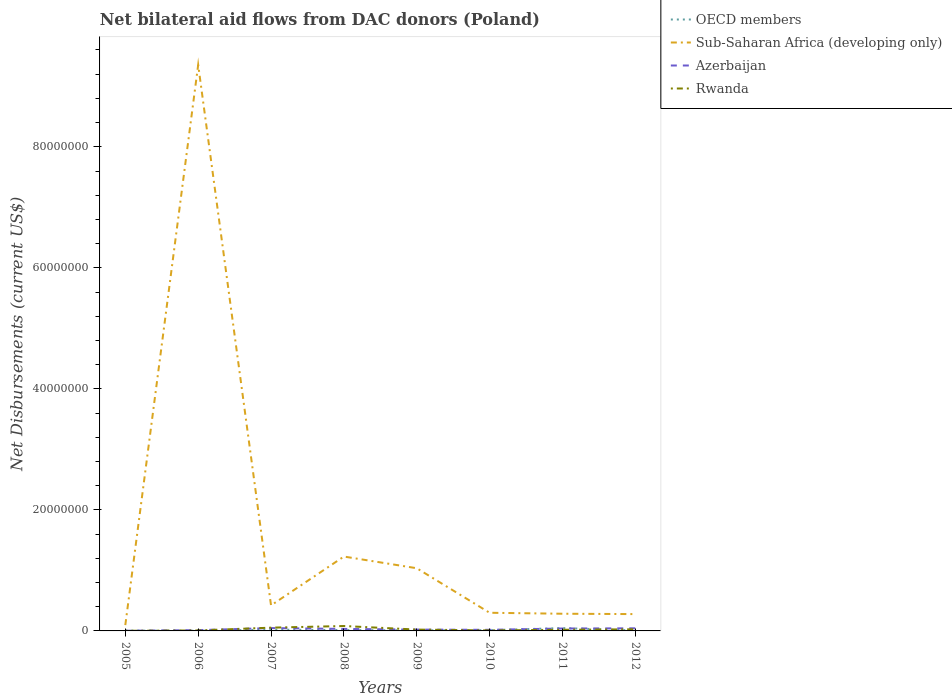How many different coloured lines are there?
Provide a succinct answer. 4. Is the number of lines equal to the number of legend labels?
Your response must be concise. Yes. Across all years, what is the maximum net bilateral aid flows in Sub-Saharan Africa (developing only)?
Offer a very short reply. 9.60e+05. What is the total net bilateral aid flows in Sub-Saharan Africa (developing only) in the graph?
Provide a short and direct response. 1.38e+06. What is the difference between the highest and the second highest net bilateral aid flows in Rwanda?
Your answer should be very brief. 7.90e+05. Does the graph contain any zero values?
Give a very brief answer. No. Does the graph contain grids?
Your response must be concise. No. How are the legend labels stacked?
Your answer should be very brief. Vertical. What is the title of the graph?
Your response must be concise. Net bilateral aid flows from DAC donors (Poland). What is the label or title of the X-axis?
Give a very brief answer. Years. What is the label or title of the Y-axis?
Keep it short and to the point. Net Disbursements (current US$). What is the Net Disbursements (current US$) in Sub-Saharan Africa (developing only) in 2005?
Provide a short and direct response. 9.60e+05. What is the Net Disbursements (current US$) of Azerbaijan in 2005?
Your answer should be compact. 3.00e+04. What is the Net Disbursements (current US$) in OECD members in 2006?
Keep it short and to the point. 3.00e+04. What is the Net Disbursements (current US$) of Sub-Saharan Africa (developing only) in 2006?
Make the answer very short. 9.35e+07. What is the Net Disbursements (current US$) in Sub-Saharan Africa (developing only) in 2007?
Provide a succinct answer. 4.22e+06. What is the Net Disbursements (current US$) in Azerbaijan in 2007?
Give a very brief answer. 4.70e+05. What is the Net Disbursements (current US$) in Rwanda in 2007?
Your answer should be compact. 5.40e+05. What is the Net Disbursements (current US$) in Sub-Saharan Africa (developing only) in 2008?
Your response must be concise. 1.23e+07. What is the Net Disbursements (current US$) in Azerbaijan in 2008?
Keep it short and to the point. 3.30e+05. What is the Net Disbursements (current US$) of Rwanda in 2008?
Your response must be concise. 8.10e+05. What is the Net Disbursements (current US$) in Sub-Saharan Africa (developing only) in 2009?
Your response must be concise. 1.04e+07. What is the Net Disbursements (current US$) in Azerbaijan in 2009?
Keep it short and to the point. 2.20e+05. What is the Net Disbursements (current US$) in Rwanda in 2009?
Provide a short and direct response. 2.20e+05. What is the Net Disbursements (current US$) of OECD members in 2010?
Your answer should be very brief. 1.20e+05. What is the Net Disbursements (current US$) of Azerbaijan in 2010?
Offer a terse response. 1.80e+05. What is the Net Disbursements (current US$) of Rwanda in 2010?
Ensure brevity in your answer.  8.00e+04. What is the Net Disbursements (current US$) in Sub-Saharan Africa (developing only) in 2011?
Your answer should be very brief. 2.84e+06. What is the Net Disbursements (current US$) of OECD members in 2012?
Ensure brevity in your answer.  7.00e+04. What is the Net Disbursements (current US$) in Sub-Saharan Africa (developing only) in 2012?
Your answer should be compact. 2.78e+06. What is the Net Disbursements (current US$) of Rwanda in 2012?
Offer a very short reply. 2.70e+05. Across all years, what is the maximum Net Disbursements (current US$) in Sub-Saharan Africa (developing only)?
Your answer should be compact. 9.35e+07. Across all years, what is the maximum Net Disbursements (current US$) of Azerbaijan?
Offer a terse response. 4.70e+05. Across all years, what is the maximum Net Disbursements (current US$) of Rwanda?
Provide a succinct answer. 8.10e+05. Across all years, what is the minimum Net Disbursements (current US$) of OECD members?
Offer a very short reply. 3.00e+04. Across all years, what is the minimum Net Disbursements (current US$) in Sub-Saharan Africa (developing only)?
Your answer should be very brief. 9.60e+05. What is the total Net Disbursements (current US$) of OECD members in the graph?
Your answer should be compact. 1.18e+06. What is the total Net Disbursements (current US$) in Sub-Saharan Africa (developing only) in the graph?
Keep it short and to the point. 1.30e+08. What is the total Net Disbursements (current US$) of Azerbaijan in the graph?
Ensure brevity in your answer.  2.19e+06. What is the total Net Disbursements (current US$) of Rwanda in the graph?
Provide a short and direct response. 2.21e+06. What is the difference between the Net Disbursements (current US$) of Sub-Saharan Africa (developing only) in 2005 and that in 2006?
Ensure brevity in your answer.  -9.26e+07. What is the difference between the Net Disbursements (current US$) of Azerbaijan in 2005 and that in 2006?
Your answer should be compact. -1.00e+05. What is the difference between the Net Disbursements (current US$) in Rwanda in 2005 and that in 2006?
Your answer should be compact. -6.00e+04. What is the difference between the Net Disbursements (current US$) in Sub-Saharan Africa (developing only) in 2005 and that in 2007?
Keep it short and to the point. -3.26e+06. What is the difference between the Net Disbursements (current US$) of Azerbaijan in 2005 and that in 2007?
Provide a short and direct response. -4.40e+05. What is the difference between the Net Disbursements (current US$) in Rwanda in 2005 and that in 2007?
Provide a short and direct response. -5.20e+05. What is the difference between the Net Disbursements (current US$) of Sub-Saharan Africa (developing only) in 2005 and that in 2008?
Provide a succinct answer. -1.13e+07. What is the difference between the Net Disbursements (current US$) of Rwanda in 2005 and that in 2008?
Your answer should be very brief. -7.90e+05. What is the difference between the Net Disbursements (current US$) in Sub-Saharan Africa (developing only) in 2005 and that in 2009?
Your answer should be compact. -9.40e+06. What is the difference between the Net Disbursements (current US$) of Azerbaijan in 2005 and that in 2009?
Provide a short and direct response. -1.90e+05. What is the difference between the Net Disbursements (current US$) in OECD members in 2005 and that in 2010?
Keep it short and to the point. -7.00e+04. What is the difference between the Net Disbursements (current US$) of Sub-Saharan Africa (developing only) in 2005 and that in 2010?
Keep it short and to the point. -2.04e+06. What is the difference between the Net Disbursements (current US$) in Azerbaijan in 2005 and that in 2010?
Ensure brevity in your answer.  -1.50e+05. What is the difference between the Net Disbursements (current US$) of OECD members in 2005 and that in 2011?
Your answer should be very brief. -4.20e+05. What is the difference between the Net Disbursements (current US$) of Sub-Saharan Africa (developing only) in 2005 and that in 2011?
Your answer should be very brief. -1.88e+06. What is the difference between the Net Disbursements (current US$) of Azerbaijan in 2005 and that in 2011?
Keep it short and to the point. -3.70e+05. What is the difference between the Net Disbursements (current US$) in Rwanda in 2005 and that in 2011?
Provide a short and direct response. -1.70e+05. What is the difference between the Net Disbursements (current US$) of OECD members in 2005 and that in 2012?
Your answer should be compact. -2.00e+04. What is the difference between the Net Disbursements (current US$) in Sub-Saharan Africa (developing only) in 2005 and that in 2012?
Keep it short and to the point. -1.82e+06. What is the difference between the Net Disbursements (current US$) in Azerbaijan in 2005 and that in 2012?
Your answer should be very brief. -4.00e+05. What is the difference between the Net Disbursements (current US$) in Rwanda in 2005 and that in 2012?
Your answer should be compact. -2.50e+05. What is the difference between the Net Disbursements (current US$) in Sub-Saharan Africa (developing only) in 2006 and that in 2007?
Keep it short and to the point. 8.93e+07. What is the difference between the Net Disbursements (current US$) in Rwanda in 2006 and that in 2007?
Provide a succinct answer. -4.60e+05. What is the difference between the Net Disbursements (current US$) of OECD members in 2006 and that in 2008?
Make the answer very short. -1.10e+05. What is the difference between the Net Disbursements (current US$) in Sub-Saharan Africa (developing only) in 2006 and that in 2008?
Give a very brief answer. 8.12e+07. What is the difference between the Net Disbursements (current US$) of Rwanda in 2006 and that in 2008?
Offer a terse response. -7.30e+05. What is the difference between the Net Disbursements (current US$) of OECD members in 2006 and that in 2009?
Make the answer very short. -6.00e+04. What is the difference between the Net Disbursements (current US$) in Sub-Saharan Africa (developing only) in 2006 and that in 2009?
Provide a short and direct response. 8.32e+07. What is the difference between the Net Disbursements (current US$) of Azerbaijan in 2006 and that in 2009?
Your response must be concise. -9.00e+04. What is the difference between the Net Disbursements (current US$) in Sub-Saharan Africa (developing only) in 2006 and that in 2010?
Offer a terse response. 9.05e+07. What is the difference between the Net Disbursements (current US$) of Rwanda in 2006 and that in 2010?
Keep it short and to the point. 0. What is the difference between the Net Disbursements (current US$) in OECD members in 2006 and that in 2011?
Keep it short and to the point. -4.40e+05. What is the difference between the Net Disbursements (current US$) of Sub-Saharan Africa (developing only) in 2006 and that in 2011?
Your response must be concise. 9.07e+07. What is the difference between the Net Disbursements (current US$) in Azerbaijan in 2006 and that in 2011?
Give a very brief answer. -2.70e+05. What is the difference between the Net Disbursements (current US$) in Sub-Saharan Africa (developing only) in 2006 and that in 2012?
Ensure brevity in your answer.  9.08e+07. What is the difference between the Net Disbursements (current US$) of Rwanda in 2006 and that in 2012?
Ensure brevity in your answer.  -1.90e+05. What is the difference between the Net Disbursements (current US$) of Sub-Saharan Africa (developing only) in 2007 and that in 2008?
Provide a short and direct response. -8.07e+06. What is the difference between the Net Disbursements (current US$) of Azerbaijan in 2007 and that in 2008?
Provide a succinct answer. 1.40e+05. What is the difference between the Net Disbursements (current US$) in Rwanda in 2007 and that in 2008?
Keep it short and to the point. -2.70e+05. What is the difference between the Net Disbursements (current US$) in Sub-Saharan Africa (developing only) in 2007 and that in 2009?
Your answer should be compact. -6.14e+06. What is the difference between the Net Disbursements (current US$) of Rwanda in 2007 and that in 2009?
Give a very brief answer. 3.20e+05. What is the difference between the Net Disbursements (current US$) in Sub-Saharan Africa (developing only) in 2007 and that in 2010?
Your response must be concise. 1.22e+06. What is the difference between the Net Disbursements (current US$) in Azerbaijan in 2007 and that in 2010?
Your answer should be very brief. 2.90e+05. What is the difference between the Net Disbursements (current US$) of Rwanda in 2007 and that in 2010?
Keep it short and to the point. 4.60e+05. What is the difference between the Net Disbursements (current US$) of OECD members in 2007 and that in 2011?
Offer a terse response. -2.60e+05. What is the difference between the Net Disbursements (current US$) in Sub-Saharan Africa (developing only) in 2007 and that in 2011?
Offer a terse response. 1.38e+06. What is the difference between the Net Disbursements (current US$) of Azerbaijan in 2007 and that in 2011?
Keep it short and to the point. 7.00e+04. What is the difference between the Net Disbursements (current US$) of Rwanda in 2007 and that in 2011?
Provide a short and direct response. 3.50e+05. What is the difference between the Net Disbursements (current US$) of OECD members in 2007 and that in 2012?
Make the answer very short. 1.40e+05. What is the difference between the Net Disbursements (current US$) of Sub-Saharan Africa (developing only) in 2007 and that in 2012?
Offer a very short reply. 1.44e+06. What is the difference between the Net Disbursements (current US$) of Rwanda in 2007 and that in 2012?
Give a very brief answer. 2.70e+05. What is the difference between the Net Disbursements (current US$) in OECD members in 2008 and that in 2009?
Your answer should be very brief. 5.00e+04. What is the difference between the Net Disbursements (current US$) of Sub-Saharan Africa (developing only) in 2008 and that in 2009?
Your answer should be very brief. 1.93e+06. What is the difference between the Net Disbursements (current US$) of Azerbaijan in 2008 and that in 2009?
Your answer should be compact. 1.10e+05. What is the difference between the Net Disbursements (current US$) in Rwanda in 2008 and that in 2009?
Offer a terse response. 5.90e+05. What is the difference between the Net Disbursements (current US$) in Sub-Saharan Africa (developing only) in 2008 and that in 2010?
Keep it short and to the point. 9.29e+06. What is the difference between the Net Disbursements (current US$) in Rwanda in 2008 and that in 2010?
Ensure brevity in your answer.  7.30e+05. What is the difference between the Net Disbursements (current US$) in OECD members in 2008 and that in 2011?
Offer a terse response. -3.30e+05. What is the difference between the Net Disbursements (current US$) of Sub-Saharan Africa (developing only) in 2008 and that in 2011?
Give a very brief answer. 9.45e+06. What is the difference between the Net Disbursements (current US$) in Rwanda in 2008 and that in 2011?
Your answer should be compact. 6.20e+05. What is the difference between the Net Disbursements (current US$) in OECD members in 2008 and that in 2012?
Ensure brevity in your answer.  7.00e+04. What is the difference between the Net Disbursements (current US$) of Sub-Saharan Africa (developing only) in 2008 and that in 2012?
Offer a very short reply. 9.51e+06. What is the difference between the Net Disbursements (current US$) of Rwanda in 2008 and that in 2012?
Offer a terse response. 5.40e+05. What is the difference between the Net Disbursements (current US$) of OECD members in 2009 and that in 2010?
Your answer should be very brief. -3.00e+04. What is the difference between the Net Disbursements (current US$) in Sub-Saharan Africa (developing only) in 2009 and that in 2010?
Provide a succinct answer. 7.36e+06. What is the difference between the Net Disbursements (current US$) in OECD members in 2009 and that in 2011?
Give a very brief answer. -3.80e+05. What is the difference between the Net Disbursements (current US$) of Sub-Saharan Africa (developing only) in 2009 and that in 2011?
Offer a terse response. 7.52e+06. What is the difference between the Net Disbursements (current US$) in Rwanda in 2009 and that in 2011?
Your answer should be compact. 3.00e+04. What is the difference between the Net Disbursements (current US$) of Sub-Saharan Africa (developing only) in 2009 and that in 2012?
Your answer should be very brief. 7.58e+06. What is the difference between the Net Disbursements (current US$) of Azerbaijan in 2009 and that in 2012?
Your response must be concise. -2.10e+05. What is the difference between the Net Disbursements (current US$) in Rwanda in 2009 and that in 2012?
Keep it short and to the point. -5.00e+04. What is the difference between the Net Disbursements (current US$) in OECD members in 2010 and that in 2011?
Ensure brevity in your answer.  -3.50e+05. What is the difference between the Net Disbursements (current US$) in Sub-Saharan Africa (developing only) in 2010 and that in 2011?
Keep it short and to the point. 1.60e+05. What is the difference between the Net Disbursements (current US$) of Azerbaijan in 2010 and that in 2011?
Ensure brevity in your answer.  -2.20e+05. What is the difference between the Net Disbursements (current US$) in Rwanda in 2010 and that in 2011?
Give a very brief answer. -1.10e+05. What is the difference between the Net Disbursements (current US$) of OECD members in 2010 and that in 2012?
Ensure brevity in your answer.  5.00e+04. What is the difference between the Net Disbursements (current US$) in OECD members in 2005 and the Net Disbursements (current US$) in Sub-Saharan Africa (developing only) in 2006?
Offer a very short reply. -9.35e+07. What is the difference between the Net Disbursements (current US$) of Sub-Saharan Africa (developing only) in 2005 and the Net Disbursements (current US$) of Azerbaijan in 2006?
Provide a short and direct response. 8.30e+05. What is the difference between the Net Disbursements (current US$) in Sub-Saharan Africa (developing only) in 2005 and the Net Disbursements (current US$) in Rwanda in 2006?
Your response must be concise. 8.80e+05. What is the difference between the Net Disbursements (current US$) in Azerbaijan in 2005 and the Net Disbursements (current US$) in Rwanda in 2006?
Give a very brief answer. -5.00e+04. What is the difference between the Net Disbursements (current US$) of OECD members in 2005 and the Net Disbursements (current US$) of Sub-Saharan Africa (developing only) in 2007?
Give a very brief answer. -4.17e+06. What is the difference between the Net Disbursements (current US$) in OECD members in 2005 and the Net Disbursements (current US$) in Azerbaijan in 2007?
Give a very brief answer. -4.20e+05. What is the difference between the Net Disbursements (current US$) in OECD members in 2005 and the Net Disbursements (current US$) in Rwanda in 2007?
Your answer should be very brief. -4.90e+05. What is the difference between the Net Disbursements (current US$) of Sub-Saharan Africa (developing only) in 2005 and the Net Disbursements (current US$) of Azerbaijan in 2007?
Your answer should be very brief. 4.90e+05. What is the difference between the Net Disbursements (current US$) of Azerbaijan in 2005 and the Net Disbursements (current US$) of Rwanda in 2007?
Keep it short and to the point. -5.10e+05. What is the difference between the Net Disbursements (current US$) in OECD members in 2005 and the Net Disbursements (current US$) in Sub-Saharan Africa (developing only) in 2008?
Your answer should be very brief. -1.22e+07. What is the difference between the Net Disbursements (current US$) in OECD members in 2005 and the Net Disbursements (current US$) in Azerbaijan in 2008?
Make the answer very short. -2.80e+05. What is the difference between the Net Disbursements (current US$) in OECD members in 2005 and the Net Disbursements (current US$) in Rwanda in 2008?
Provide a succinct answer. -7.60e+05. What is the difference between the Net Disbursements (current US$) of Sub-Saharan Africa (developing only) in 2005 and the Net Disbursements (current US$) of Azerbaijan in 2008?
Give a very brief answer. 6.30e+05. What is the difference between the Net Disbursements (current US$) of Azerbaijan in 2005 and the Net Disbursements (current US$) of Rwanda in 2008?
Make the answer very short. -7.80e+05. What is the difference between the Net Disbursements (current US$) of OECD members in 2005 and the Net Disbursements (current US$) of Sub-Saharan Africa (developing only) in 2009?
Your answer should be very brief. -1.03e+07. What is the difference between the Net Disbursements (current US$) in OECD members in 2005 and the Net Disbursements (current US$) in Rwanda in 2009?
Provide a short and direct response. -1.70e+05. What is the difference between the Net Disbursements (current US$) of Sub-Saharan Africa (developing only) in 2005 and the Net Disbursements (current US$) of Azerbaijan in 2009?
Your answer should be very brief. 7.40e+05. What is the difference between the Net Disbursements (current US$) of Sub-Saharan Africa (developing only) in 2005 and the Net Disbursements (current US$) of Rwanda in 2009?
Make the answer very short. 7.40e+05. What is the difference between the Net Disbursements (current US$) of Azerbaijan in 2005 and the Net Disbursements (current US$) of Rwanda in 2009?
Your response must be concise. -1.90e+05. What is the difference between the Net Disbursements (current US$) in OECD members in 2005 and the Net Disbursements (current US$) in Sub-Saharan Africa (developing only) in 2010?
Make the answer very short. -2.95e+06. What is the difference between the Net Disbursements (current US$) of OECD members in 2005 and the Net Disbursements (current US$) of Azerbaijan in 2010?
Make the answer very short. -1.30e+05. What is the difference between the Net Disbursements (current US$) of Sub-Saharan Africa (developing only) in 2005 and the Net Disbursements (current US$) of Azerbaijan in 2010?
Your answer should be very brief. 7.80e+05. What is the difference between the Net Disbursements (current US$) in Sub-Saharan Africa (developing only) in 2005 and the Net Disbursements (current US$) in Rwanda in 2010?
Provide a succinct answer. 8.80e+05. What is the difference between the Net Disbursements (current US$) of Azerbaijan in 2005 and the Net Disbursements (current US$) of Rwanda in 2010?
Make the answer very short. -5.00e+04. What is the difference between the Net Disbursements (current US$) of OECD members in 2005 and the Net Disbursements (current US$) of Sub-Saharan Africa (developing only) in 2011?
Provide a succinct answer. -2.79e+06. What is the difference between the Net Disbursements (current US$) of OECD members in 2005 and the Net Disbursements (current US$) of Azerbaijan in 2011?
Your answer should be compact. -3.50e+05. What is the difference between the Net Disbursements (current US$) in Sub-Saharan Africa (developing only) in 2005 and the Net Disbursements (current US$) in Azerbaijan in 2011?
Provide a short and direct response. 5.60e+05. What is the difference between the Net Disbursements (current US$) in Sub-Saharan Africa (developing only) in 2005 and the Net Disbursements (current US$) in Rwanda in 2011?
Your response must be concise. 7.70e+05. What is the difference between the Net Disbursements (current US$) of OECD members in 2005 and the Net Disbursements (current US$) of Sub-Saharan Africa (developing only) in 2012?
Provide a short and direct response. -2.73e+06. What is the difference between the Net Disbursements (current US$) in OECD members in 2005 and the Net Disbursements (current US$) in Azerbaijan in 2012?
Provide a succinct answer. -3.80e+05. What is the difference between the Net Disbursements (current US$) in Sub-Saharan Africa (developing only) in 2005 and the Net Disbursements (current US$) in Azerbaijan in 2012?
Offer a very short reply. 5.30e+05. What is the difference between the Net Disbursements (current US$) of Sub-Saharan Africa (developing only) in 2005 and the Net Disbursements (current US$) of Rwanda in 2012?
Ensure brevity in your answer.  6.90e+05. What is the difference between the Net Disbursements (current US$) in Azerbaijan in 2005 and the Net Disbursements (current US$) in Rwanda in 2012?
Ensure brevity in your answer.  -2.40e+05. What is the difference between the Net Disbursements (current US$) of OECD members in 2006 and the Net Disbursements (current US$) of Sub-Saharan Africa (developing only) in 2007?
Offer a terse response. -4.19e+06. What is the difference between the Net Disbursements (current US$) in OECD members in 2006 and the Net Disbursements (current US$) in Azerbaijan in 2007?
Make the answer very short. -4.40e+05. What is the difference between the Net Disbursements (current US$) of OECD members in 2006 and the Net Disbursements (current US$) of Rwanda in 2007?
Offer a very short reply. -5.10e+05. What is the difference between the Net Disbursements (current US$) in Sub-Saharan Africa (developing only) in 2006 and the Net Disbursements (current US$) in Azerbaijan in 2007?
Offer a terse response. 9.31e+07. What is the difference between the Net Disbursements (current US$) in Sub-Saharan Africa (developing only) in 2006 and the Net Disbursements (current US$) in Rwanda in 2007?
Offer a very short reply. 9.30e+07. What is the difference between the Net Disbursements (current US$) in Azerbaijan in 2006 and the Net Disbursements (current US$) in Rwanda in 2007?
Make the answer very short. -4.10e+05. What is the difference between the Net Disbursements (current US$) in OECD members in 2006 and the Net Disbursements (current US$) in Sub-Saharan Africa (developing only) in 2008?
Your answer should be very brief. -1.23e+07. What is the difference between the Net Disbursements (current US$) in OECD members in 2006 and the Net Disbursements (current US$) in Rwanda in 2008?
Keep it short and to the point. -7.80e+05. What is the difference between the Net Disbursements (current US$) of Sub-Saharan Africa (developing only) in 2006 and the Net Disbursements (current US$) of Azerbaijan in 2008?
Provide a short and direct response. 9.32e+07. What is the difference between the Net Disbursements (current US$) in Sub-Saharan Africa (developing only) in 2006 and the Net Disbursements (current US$) in Rwanda in 2008?
Keep it short and to the point. 9.27e+07. What is the difference between the Net Disbursements (current US$) of Azerbaijan in 2006 and the Net Disbursements (current US$) of Rwanda in 2008?
Give a very brief answer. -6.80e+05. What is the difference between the Net Disbursements (current US$) of OECD members in 2006 and the Net Disbursements (current US$) of Sub-Saharan Africa (developing only) in 2009?
Make the answer very short. -1.03e+07. What is the difference between the Net Disbursements (current US$) of Sub-Saharan Africa (developing only) in 2006 and the Net Disbursements (current US$) of Azerbaijan in 2009?
Make the answer very short. 9.33e+07. What is the difference between the Net Disbursements (current US$) in Sub-Saharan Africa (developing only) in 2006 and the Net Disbursements (current US$) in Rwanda in 2009?
Provide a short and direct response. 9.33e+07. What is the difference between the Net Disbursements (current US$) in Azerbaijan in 2006 and the Net Disbursements (current US$) in Rwanda in 2009?
Provide a succinct answer. -9.00e+04. What is the difference between the Net Disbursements (current US$) in OECD members in 2006 and the Net Disbursements (current US$) in Sub-Saharan Africa (developing only) in 2010?
Offer a terse response. -2.97e+06. What is the difference between the Net Disbursements (current US$) of OECD members in 2006 and the Net Disbursements (current US$) of Azerbaijan in 2010?
Your answer should be compact. -1.50e+05. What is the difference between the Net Disbursements (current US$) of OECD members in 2006 and the Net Disbursements (current US$) of Rwanda in 2010?
Provide a short and direct response. -5.00e+04. What is the difference between the Net Disbursements (current US$) of Sub-Saharan Africa (developing only) in 2006 and the Net Disbursements (current US$) of Azerbaijan in 2010?
Offer a terse response. 9.34e+07. What is the difference between the Net Disbursements (current US$) of Sub-Saharan Africa (developing only) in 2006 and the Net Disbursements (current US$) of Rwanda in 2010?
Offer a terse response. 9.35e+07. What is the difference between the Net Disbursements (current US$) in OECD members in 2006 and the Net Disbursements (current US$) in Sub-Saharan Africa (developing only) in 2011?
Provide a succinct answer. -2.81e+06. What is the difference between the Net Disbursements (current US$) of OECD members in 2006 and the Net Disbursements (current US$) of Azerbaijan in 2011?
Keep it short and to the point. -3.70e+05. What is the difference between the Net Disbursements (current US$) in Sub-Saharan Africa (developing only) in 2006 and the Net Disbursements (current US$) in Azerbaijan in 2011?
Offer a very short reply. 9.31e+07. What is the difference between the Net Disbursements (current US$) of Sub-Saharan Africa (developing only) in 2006 and the Net Disbursements (current US$) of Rwanda in 2011?
Offer a terse response. 9.34e+07. What is the difference between the Net Disbursements (current US$) in OECD members in 2006 and the Net Disbursements (current US$) in Sub-Saharan Africa (developing only) in 2012?
Your answer should be very brief. -2.75e+06. What is the difference between the Net Disbursements (current US$) in OECD members in 2006 and the Net Disbursements (current US$) in Azerbaijan in 2012?
Make the answer very short. -4.00e+05. What is the difference between the Net Disbursements (current US$) of OECD members in 2006 and the Net Disbursements (current US$) of Rwanda in 2012?
Your answer should be compact. -2.40e+05. What is the difference between the Net Disbursements (current US$) in Sub-Saharan Africa (developing only) in 2006 and the Net Disbursements (current US$) in Azerbaijan in 2012?
Your answer should be very brief. 9.31e+07. What is the difference between the Net Disbursements (current US$) in Sub-Saharan Africa (developing only) in 2006 and the Net Disbursements (current US$) in Rwanda in 2012?
Give a very brief answer. 9.33e+07. What is the difference between the Net Disbursements (current US$) in OECD members in 2007 and the Net Disbursements (current US$) in Sub-Saharan Africa (developing only) in 2008?
Offer a terse response. -1.21e+07. What is the difference between the Net Disbursements (current US$) in OECD members in 2007 and the Net Disbursements (current US$) in Rwanda in 2008?
Provide a succinct answer. -6.00e+05. What is the difference between the Net Disbursements (current US$) of Sub-Saharan Africa (developing only) in 2007 and the Net Disbursements (current US$) of Azerbaijan in 2008?
Provide a succinct answer. 3.89e+06. What is the difference between the Net Disbursements (current US$) of Sub-Saharan Africa (developing only) in 2007 and the Net Disbursements (current US$) of Rwanda in 2008?
Keep it short and to the point. 3.41e+06. What is the difference between the Net Disbursements (current US$) of Azerbaijan in 2007 and the Net Disbursements (current US$) of Rwanda in 2008?
Provide a short and direct response. -3.40e+05. What is the difference between the Net Disbursements (current US$) in OECD members in 2007 and the Net Disbursements (current US$) in Sub-Saharan Africa (developing only) in 2009?
Make the answer very short. -1.02e+07. What is the difference between the Net Disbursements (current US$) of OECD members in 2007 and the Net Disbursements (current US$) of Azerbaijan in 2009?
Your answer should be very brief. -10000. What is the difference between the Net Disbursements (current US$) of Sub-Saharan Africa (developing only) in 2007 and the Net Disbursements (current US$) of Azerbaijan in 2009?
Your answer should be compact. 4.00e+06. What is the difference between the Net Disbursements (current US$) of OECD members in 2007 and the Net Disbursements (current US$) of Sub-Saharan Africa (developing only) in 2010?
Provide a succinct answer. -2.79e+06. What is the difference between the Net Disbursements (current US$) in OECD members in 2007 and the Net Disbursements (current US$) in Azerbaijan in 2010?
Make the answer very short. 3.00e+04. What is the difference between the Net Disbursements (current US$) of Sub-Saharan Africa (developing only) in 2007 and the Net Disbursements (current US$) of Azerbaijan in 2010?
Offer a very short reply. 4.04e+06. What is the difference between the Net Disbursements (current US$) of Sub-Saharan Africa (developing only) in 2007 and the Net Disbursements (current US$) of Rwanda in 2010?
Keep it short and to the point. 4.14e+06. What is the difference between the Net Disbursements (current US$) in OECD members in 2007 and the Net Disbursements (current US$) in Sub-Saharan Africa (developing only) in 2011?
Your answer should be compact. -2.63e+06. What is the difference between the Net Disbursements (current US$) of OECD members in 2007 and the Net Disbursements (current US$) of Azerbaijan in 2011?
Your answer should be compact. -1.90e+05. What is the difference between the Net Disbursements (current US$) in OECD members in 2007 and the Net Disbursements (current US$) in Rwanda in 2011?
Give a very brief answer. 2.00e+04. What is the difference between the Net Disbursements (current US$) in Sub-Saharan Africa (developing only) in 2007 and the Net Disbursements (current US$) in Azerbaijan in 2011?
Offer a very short reply. 3.82e+06. What is the difference between the Net Disbursements (current US$) of Sub-Saharan Africa (developing only) in 2007 and the Net Disbursements (current US$) of Rwanda in 2011?
Ensure brevity in your answer.  4.03e+06. What is the difference between the Net Disbursements (current US$) in OECD members in 2007 and the Net Disbursements (current US$) in Sub-Saharan Africa (developing only) in 2012?
Keep it short and to the point. -2.57e+06. What is the difference between the Net Disbursements (current US$) in Sub-Saharan Africa (developing only) in 2007 and the Net Disbursements (current US$) in Azerbaijan in 2012?
Provide a short and direct response. 3.79e+06. What is the difference between the Net Disbursements (current US$) of Sub-Saharan Africa (developing only) in 2007 and the Net Disbursements (current US$) of Rwanda in 2012?
Make the answer very short. 3.95e+06. What is the difference between the Net Disbursements (current US$) of OECD members in 2008 and the Net Disbursements (current US$) of Sub-Saharan Africa (developing only) in 2009?
Ensure brevity in your answer.  -1.02e+07. What is the difference between the Net Disbursements (current US$) in OECD members in 2008 and the Net Disbursements (current US$) in Azerbaijan in 2009?
Offer a terse response. -8.00e+04. What is the difference between the Net Disbursements (current US$) in OECD members in 2008 and the Net Disbursements (current US$) in Rwanda in 2009?
Your answer should be compact. -8.00e+04. What is the difference between the Net Disbursements (current US$) in Sub-Saharan Africa (developing only) in 2008 and the Net Disbursements (current US$) in Azerbaijan in 2009?
Your response must be concise. 1.21e+07. What is the difference between the Net Disbursements (current US$) in Sub-Saharan Africa (developing only) in 2008 and the Net Disbursements (current US$) in Rwanda in 2009?
Provide a succinct answer. 1.21e+07. What is the difference between the Net Disbursements (current US$) in Azerbaijan in 2008 and the Net Disbursements (current US$) in Rwanda in 2009?
Give a very brief answer. 1.10e+05. What is the difference between the Net Disbursements (current US$) of OECD members in 2008 and the Net Disbursements (current US$) of Sub-Saharan Africa (developing only) in 2010?
Make the answer very short. -2.86e+06. What is the difference between the Net Disbursements (current US$) in OECD members in 2008 and the Net Disbursements (current US$) in Rwanda in 2010?
Your answer should be compact. 6.00e+04. What is the difference between the Net Disbursements (current US$) of Sub-Saharan Africa (developing only) in 2008 and the Net Disbursements (current US$) of Azerbaijan in 2010?
Your answer should be very brief. 1.21e+07. What is the difference between the Net Disbursements (current US$) in Sub-Saharan Africa (developing only) in 2008 and the Net Disbursements (current US$) in Rwanda in 2010?
Make the answer very short. 1.22e+07. What is the difference between the Net Disbursements (current US$) in Azerbaijan in 2008 and the Net Disbursements (current US$) in Rwanda in 2010?
Ensure brevity in your answer.  2.50e+05. What is the difference between the Net Disbursements (current US$) in OECD members in 2008 and the Net Disbursements (current US$) in Sub-Saharan Africa (developing only) in 2011?
Keep it short and to the point. -2.70e+06. What is the difference between the Net Disbursements (current US$) in Sub-Saharan Africa (developing only) in 2008 and the Net Disbursements (current US$) in Azerbaijan in 2011?
Make the answer very short. 1.19e+07. What is the difference between the Net Disbursements (current US$) of Sub-Saharan Africa (developing only) in 2008 and the Net Disbursements (current US$) of Rwanda in 2011?
Keep it short and to the point. 1.21e+07. What is the difference between the Net Disbursements (current US$) of Azerbaijan in 2008 and the Net Disbursements (current US$) of Rwanda in 2011?
Give a very brief answer. 1.40e+05. What is the difference between the Net Disbursements (current US$) in OECD members in 2008 and the Net Disbursements (current US$) in Sub-Saharan Africa (developing only) in 2012?
Keep it short and to the point. -2.64e+06. What is the difference between the Net Disbursements (current US$) of OECD members in 2008 and the Net Disbursements (current US$) of Azerbaijan in 2012?
Your answer should be compact. -2.90e+05. What is the difference between the Net Disbursements (current US$) of OECD members in 2008 and the Net Disbursements (current US$) of Rwanda in 2012?
Give a very brief answer. -1.30e+05. What is the difference between the Net Disbursements (current US$) of Sub-Saharan Africa (developing only) in 2008 and the Net Disbursements (current US$) of Azerbaijan in 2012?
Ensure brevity in your answer.  1.19e+07. What is the difference between the Net Disbursements (current US$) in Sub-Saharan Africa (developing only) in 2008 and the Net Disbursements (current US$) in Rwanda in 2012?
Give a very brief answer. 1.20e+07. What is the difference between the Net Disbursements (current US$) in Azerbaijan in 2008 and the Net Disbursements (current US$) in Rwanda in 2012?
Provide a succinct answer. 6.00e+04. What is the difference between the Net Disbursements (current US$) in OECD members in 2009 and the Net Disbursements (current US$) in Sub-Saharan Africa (developing only) in 2010?
Provide a short and direct response. -2.91e+06. What is the difference between the Net Disbursements (current US$) of Sub-Saharan Africa (developing only) in 2009 and the Net Disbursements (current US$) of Azerbaijan in 2010?
Give a very brief answer. 1.02e+07. What is the difference between the Net Disbursements (current US$) of Sub-Saharan Africa (developing only) in 2009 and the Net Disbursements (current US$) of Rwanda in 2010?
Offer a very short reply. 1.03e+07. What is the difference between the Net Disbursements (current US$) of OECD members in 2009 and the Net Disbursements (current US$) of Sub-Saharan Africa (developing only) in 2011?
Your response must be concise. -2.75e+06. What is the difference between the Net Disbursements (current US$) in OECD members in 2009 and the Net Disbursements (current US$) in Azerbaijan in 2011?
Give a very brief answer. -3.10e+05. What is the difference between the Net Disbursements (current US$) of OECD members in 2009 and the Net Disbursements (current US$) of Rwanda in 2011?
Provide a succinct answer. -1.00e+05. What is the difference between the Net Disbursements (current US$) in Sub-Saharan Africa (developing only) in 2009 and the Net Disbursements (current US$) in Azerbaijan in 2011?
Make the answer very short. 9.96e+06. What is the difference between the Net Disbursements (current US$) in Sub-Saharan Africa (developing only) in 2009 and the Net Disbursements (current US$) in Rwanda in 2011?
Offer a very short reply. 1.02e+07. What is the difference between the Net Disbursements (current US$) in Azerbaijan in 2009 and the Net Disbursements (current US$) in Rwanda in 2011?
Provide a succinct answer. 3.00e+04. What is the difference between the Net Disbursements (current US$) of OECD members in 2009 and the Net Disbursements (current US$) of Sub-Saharan Africa (developing only) in 2012?
Give a very brief answer. -2.69e+06. What is the difference between the Net Disbursements (current US$) in OECD members in 2009 and the Net Disbursements (current US$) in Rwanda in 2012?
Your answer should be very brief. -1.80e+05. What is the difference between the Net Disbursements (current US$) of Sub-Saharan Africa (developing only) in 2009 and the Net Disbursements (current US$) of Azerbaijan in 2012?
Give a very brief answer. 9.93e+06. What is the difference between the Net Disbursements (current US$) in Sub-Saharan Africa (developing only) in 2009 and the Net Disbursements (current US$) in Rwanda in 2012?
Make the answer very short. 1.01e+07. What is the difference between the Net Disbursements (current US$) of OECD members in 2010 and the Net Disbursements (current US$) of Sub-Saharan Africa (developing only) in 2011?
Give a very brief answer. -2.72e+06. What is the difference between the Net Disbursements (current US$) of OECD members in 2010 and the Net Disbursements (current US$) of Azerbaijan in 2011?
Make the answer very short. -2.80e+05. What is the difference between the Net Disbursements (current US$) of OECD members in 2010 and the Net Disbursements (current US$) of Rwanda in 2011?
Provide a short and direct response. -7.00e+04. What is the difference between the Net Disbursements (current US$) in Sub-Saharan Africa (developing only) in 2010 and the Net Disbursements (current US$) in Azerbaijan in 2011?
Offer a very short reply. 2.60e+06. What is the difference between the Net Disbursements (current US$) of Sub-Saharan Africa (developing only) in 2010 and the Net Disbursements (current US$) of Rwanda in 2011?
Your response must be concise. 2.81e+06. What is the difference between the Net Disbursements (current US$) in OECD members in 2010 and the Net Disbursements (current US$) in Sub-Saharan Africa (developing only) in 2012?
Offer a very short reply. -2.66e+06. What is the difference between the Net Disbursements (current US$) of OECD members in 2010 and the Net Disbursements (current US$) of Azerbaijan in 2012?
Keep it short and to the point. -3.10e+05. What is the difference between the Net Disbursements (current US$) in OECD members in 2010 and the Net Disbursements (current US$) in Rwanda in 2012?
Give a very brief answer. -1.50e+05. What is the difference between the Net Disbursements (current US$) of Sub-Saharan Africa (developing only) in 2010 and the Net Disbursements (current US$) of Azerbaijan in 2012?
Make the answer very short. 2.57e+06. What is the difference between the Net Disbursements (current US$) in Sub-Saharan Africa (developing only) in 2010 and the Net Disbursements (current US$) in Rwanda in 2012?
Your response must be concise. 2.73e+06. What is the difference between the Net Disbursements (current US$) in OECD members in 2011 and the Net Disbursements (current US$) in Sub-Saharan Africa (developing only) in 2012?
Give a very brief answer. -2.31e+06. What is the difference between the Net Disbursements (current US$) of OECD members in 2011 and the Net Disbursements (current US$) of Azerbaijan in 2012?
Ensure brevity in your answer.  4.00e+04. What is the difference between the Net Disbursements (current US$) in Sub-Saharan Africa (developing only) in 2011 and the Net Disbursements (current US$) in Azerbaijan in 2012?
Ensure brevity in your answer.  2.41e+06. What is the difference between the Net Disbursements (current US$) in Sub-Saharan Africa (developing only) in 2011 and the Net Disbursements (current US$) in Rwanda in 2012?
Your answer should be compact. 2.57e+06. What is the average Net Disbursements (current US$) of OECD members per year?
Offer a terse response. 1.48e+05. What is the average Net Disbursements (current US$) of Sub-Saharan Africa (developing only) per year?
Make the answer very short. 1.62e+07. What is the average Net Disbursements (current US$) of Azerbaijan per year?
Your answer should be very brief. 2.74e+05. What is the average Net Disbursements (current US$) in Rwanda per year?
Your response must be concise. 2.76e+05. In the year 2005, what is the difference between the Net Disbursements (current US$) of OECD members and Net Disbursements (current US$) of Sub-Saharan Africa (developing only)?
Offer a very short reply. -9.10e+05. In the year 2005, what is the difference between the Net Disbursements (current US$) in Sub-Saharan Africa (developing only) and Net Disbursements (current US$) in Azerbaijan?
Give a very brief answer. 9.30e+05. In the year 2005, what is the difference between the Net Disbursements (current US$) of Sub-Saharan Africa (developing only) and Net Disbursements (current US$) of Rwanda?
Your answer should be very brief. 9.40e+05. In the year 2005, what is the difference between the Net Disbursements (current US$) of Azerbaijan and Net Disbursements (current US$) of Rwanda?
Offer a terse response. 10000. In the year 2006, what is the difference between the Net Disbursements (current US$) of OECD members and Net Disbursements (current US$) of Sub-Saharan Africa (developing only)?
Your answer should be compact. -9.35e+07. In the year 2006, what is the difference between the Net Disbursements (current US$) of OECD members and Net Disbursements (current US$) of Azerbaijan?
Ensure brevity in your answer.  -1.00e+05. In the year 2006, what is the difference between the Net Disbursements (current US$) in OECD members and Net Disbursements (current US$) in Rwanda?
Provide a short and direct response. -5.00e+04. In the year 2006, what is the difference between the Net Disbursements (current US$) in Sub-Saharan Africa (developing only) and Net Disbursements (current US$) in Azerbaijan?
Your response must be concise. 9.34e+07. In the year 2006, what is the difference between the Net Disbursements (current US$) in Sub-Saharan Africa (developing only) and Net Disbursements (current US$) in Rwanda?
Keep it short and to the point. 9.35e+07. In the year 2006, what is the difference between the Net Disbursements (current US$) of Azerbaijan and Net Disbursements (current US$) of Rwanda?
Make the answer very short. 5.00e+04. In the year 2007, what is the difference between the Net Disbursements (current US$) of OECD members and Net Disbursements (current US$) of Sub-Saharan Africa (developing only)?
Keep it short and to the point. -4.01e+06. In the year 2007, what is the difference between the Net Disbursements (current US$) in OECD members and Net Disbursements (current US$) in Azerbaijan?
Ensure brevity in your answer.  -2.60e+05. In the year 2007, what is the difference between the Net Disbursements (current US$) in OECD members and Net Disbursements (current US$) in Rwanda?
Make the answer very short. -3.30e+05. In the year 2007, what is the difference between the Net Disbursements (current US$) in Sub-Saharan Africa (developing only) and Net Disbursements (current US$) in Azerbaijan?
Make the answer very short. 3.75e+06. In the year 2007, what is the difference between the Net Disbursements (current US$) of Sub-Saharan Africa (developing only) and Net Disbursements (current US$) of Rwanda?
Your response must be concise. 3.68e+06. In the year 2007, what is the difference between the Net Disbursements (current US$) in Azerbaijan and Net Disbursements (current US$) in Rwanda?
Ensure brevity in your answer.  -7.00e+04. In the year 2008, what is the difference between the Net Disbursements (current US$) in OECD members and Net Disbursements (current US$) in Sub-Saharan Africa (developing only)?
Your response must be concise. -1.22e+07. In the year 2008, what is the difference between the Net Disbursements (current US$) in OECD members and Net Disbursements (current US$) in Azerbaijan?
Your response must be concise. -1.90e+05. In the year 2008, what is the difference between the Net Disbursements (current US$) of OECD members and Net Disbursements (current US$) of Rwanda?
Give a very brief answer. -6.70e+05. In the year 2008, what is the difference between the Net Disbursements (current US$) of Sub-Saharan Africa (developing only) and Net Disbursements (current US$) of Azerbaijan?
Keep it short and to the point. 1.20e+07. In the year 2008, what is the difference between the Net Disbursements (current US$) in Sub-Saharan Africa (developing only) and Net Disbursements (current US$) in Rwanda?
Your answer should be compact. 1.15e+07. In the year 2008, what is the difference between the Net Disbursements (current US$) of Azerbaijan and Net Disbursements (current US$) of Rwanda?
Offer a very short reply. -4.80e+05. In the year 2009, what is the difference between the Net Disbursements (current US$) in OECD members and Net Disbursements (current US$) in Sub-Saharan Africa (developing only)?
Offer a terse response. -1.03e+07. In the year 2009, what is the difference between the Net Disbursements (current US$) in OECD members and Net Disbursements (current US$) in Azerbaijan?
Make the answer very short. -1.30e+05. In the year 2009, what is the difference between the Net Disbursements (current US$) in Sub-Saharan Africa (developing only) and Net Disbursements (current US$) in Azerbaijan?
Make the answer very short. 1.01e+07. In the year 2009, what is the difference between the Net Disbursements (current US$) in Sub-Saharan Africa (developing only) and Net Disbursements (current US$) in Rwanda?
Your response must be concise. 1.01e+07. In the year 2010, what is the difference between the Net Disbursements (current US$) in OECD members and Net Disbursements (current US$) in Sub-Saharan Africa (developing only)?
Provide a short and direct response. -2.88e+06. In the year 2010, what is the difference between the Net Disbursements (current US$) of OECD members and Net Disbursements (current US$) of Azerbaijan?
Keep it short and to the point. -6.00e+04. In the year 2010, what is the difference between the Net Disbursements (current US$) in Sub-Saharan Africa (developing only) and Net Disbursements (current US$) in Azerbaijan?
Your response must be concise. 2.82e+06. In the year 2010, what is the difference between the Net Disbursements (current US$) in Sub-Saharan Africa (developing only) and Net Disbursements (current US$) in Rwanda?
Your answer should be compact. 2.92e+06. In the year 2011, what is the difference between the Net Disbursements (current US$) of OECD members and Net Disbursements (current US$) of Sub-Saharan Africa (developing only)?
Make the answer very short. -2.37e+06. In the year 2011, what is the difference between the Net Disbursements (current US$) in OECD members and Net Disbursements (current US$) in Azerbaijan?
Your response must be concise. 7.00e+04. In the year 2011, what is the difference between the Net Disbursements (current US$) in Sub-Saharan Africa (developing only) and Net Disbursements (current US$) in Azerbaijan?
Give a very brief answer. 2.44e+06. In the year 2011, what is the difference between the Net Disbursements (current US$) in Sub-Saharan Africa (developing only) and Net Disbursements (current US$) in Rwanda?
Offer a terse response. 2.65e+06. In the year 2011, what is the difference between the Net Disbursements (current US$) in Azerbaijan and Net Disbursements (current US$) in Rwanda?
Keep it short and to the point. 2.10e+05. In the year 2012, what is the difference between the Net Disbursements (current US$) of OECD members and Net Disbursements (current US$) of Sub-Saharan Africa (developing only)?
Keep it short and to the point. -2.71e+06. In the year 2012, what is the difference between the Net Disbursements (current US$) of OECD members and Net Disbursements (current US$) of Azerbaijan?
Your answer should be compact. -3.60e+05. In the year 2012, what is the difference between the Net Disbursements (current US$) in OECD members and Net Disbursements (current US$) in Rwanda?
Provide a short and direct response. -2.00e+05. In the year 2012, what is the difference between the Net Disbursements (current US$) of Sub-Saharan Africa (developing only) and Net Disbursements (current US$) of Azerbaijan?
Give a very brief answer. 2.35e+06. In the year 2012, what is the difference between the Net Disbursements (current US$) of Sub-Saharan Africa (developing only) and Net Disbursements (current US$) of Rwanda?
Your answer should be very brief. 2.51e+06. What is the ratio of the Net Disbursements (current US$) in Sub-Saharan Africa (developing only) in 2005 to that in 2006?
Make the answer very short. 0.01. What is the ratio of the Net Disbursements (current US$) in Azerbaijan in 2005 to that in 2006?
Give a very brief answer. 0.23. What is the ratio of the Net Disbursements (current US$) of Rwanda in 2005 to that in 2006?
Provide a short and direct response. 0.25. What is the ratio of the Net Disbursements (current US$) in OECD members in 2005 to that in 2007?
Give a very brief answer. 0.24. What is the ratio of the Net Disbursements (current US$) of Sub-Saharan Africa (developing only) in 2005 to that in 2007?
Offer a very short reply. 0.23. What is the ratio of the Net Disbursements (current US$) of Azerbaijan in 2005 to that in 2007?
Offer a terse response. 0.06. What is the ratio of the Net Disbursements (current US$) of Rwanda in 2005 to that in 2007?
Your answer should be very brief. 0.04. What is the ratio of the Net Disbursements (current US$) in OECD members in 2005 to that in 2008?
Provide a succinct answer. 0.36. What is the ratio of the Net Disbursements (current US$) of Sub-Saharan Africa (developing only) in 2005 to that in 2008?
Offer a very short reply. 0.08. What is the ratio of the Net Disbursements (current US$) of Azerbaijan in 2005 to that in 2008?
Give a very brief answer. 0.09. What is the ratio of the Net Disbursements (current US$) in Rwanda in 2005 to that in 2008?
Your answer should be very brief. 0.02. What is the ratio of the Net Disbursements (current US$) in OECD members in 2005 to that in 2009?
Offer a terse response. 0.56. What is the ratio of the Net Disbursements (current US$) in Sub-Saharan Africa (developing only) in 2005 to that in 2009?
Keep it short and to the point. 0.09. What is the ratio of the Net Disbursements (current US$) in Azerbaijan in 2005 to that in 2009?
Provide a succinct answer. 0.14. What is the ratio of the Net Disbursements (current US$) of Rwanda in 2005 to that in 2009?
Provide a short and direct response. 0.09. What is the ratio of the Net Disbursements (current US$) of OECD members in 2005 to that in 2010?
Your response must be concise. 0.42. What is the ratio of the Net Disbursements (current US$) in Sub-Saharan Africa (developing only) in 2005 to that in 2010?
Your answer should be very brief. 0.32. What is the ratio of the Net Disbursements (current US$) of OECD members in 2005 to that in 2011?
Your answer should be compact. 0.11. What is the ratio of the Net Disbursements (current US$) of Sub-Saharan Africa (developing only) in 2005 to that in 2011?
Provide a short and direct response. 0.34. What is the ratio of the Net Disbursements (current US$) of Azerbaijan in 2005 to that in 2011?
Offer a terse response. 0.07. What is the ratio of the Net Disbursements (current US$) in Rwanda in 2005 to that in 2011?
Your answer should be compact. 0.11. What is the ratio of the Net Disbursements (current US$) of OECD members in 2005 to that in 2012?
Your response must be concise. 0.71. What is the ratio of the Net Disbursements (current US$) in Sub-Saharan Africa (developing only) in 2005 to that in 2012?
Keep it short and to the point. 0.35. What is the ratio of the Net Disbursements (current US$) of Azerbaijan in 2005 to that in 2012?
Offer a terse response. 0.07. What is the ratio of the Net Disbursements (current US$) in Rwanda in 2005 to that in 2012?
Provide a succinct answer. 0.07. What is the ratio of the Net Disbursements (current US$) of OECD members in 2006 to that in 2007?
Your answer should be very brief. 0.14. What is the ratio of the Net Disbursements (current US$) in Sub-Saharan Africa (developing only) in 2006 to that in 2007?
Provide a short and direct response. 22.17. What is the ratio of the Net Disbursements (current US$) of Azerbaijan in 2006 to that in 2007?
Ensure brevity in your answer.  0.28. What is the ratio of the Net Disbursements (current US$) in Rwanda in 2006 to that in 2007?
Give a very brief answer. 0.15. What is the ratio of the Net Disbursements (current US$) of OECD members in 2006 to that in 2008?
Provide a succinct answer. 0.21. What is the ratio of the Net Disbursements (current US$) of Sub-Saharan Africa (developing only) in 2006 to that in 2008?
Provide a succinct answer. 7.61. What is the ratio of the Net Disbursements (current US$) of Azerbaijan in 2006 to that in 2008?
Keep it short and to the point. 0.39. What is the ratio of the Net Disbursements (current US$) in Rwanda in 2006 to that in 2008?
Your answer should be compact. 0.1. What is the ratio of the Net Disbursements (current US$) of OECD members in 2006 to that in 2009?
Provide a short and direct response. 0.33. What is the ratio of the Net Disbursements (current US$) in Sub-Saharan Africa (developing only) in 2006 to that in 2009?
Your answer should be very brief. 9.03. What is the ratio of the Net Disbursements (current US$) in Azerbaijan in 2006 to that in 2009?
Provide a succinct answer. 0.59. What is the ratio of the Net Disbursements (current US$) in Rwanda in 2006 to that in 2009?
Offer a terse response. 0.36. What is the ratio of the Net Disbursements (current US$) in OECD members in 2006 to that in 2010?
Your answer should be very brief. 0.25. What is the ratio of the Net Disbursements (current US$) of Sub-Saharan Africa (developing only) in 2006 to that in 2010?
Your answer should be very brief. 31.18. What is the ratio of the Net Disbursements (current US$) in Azerbaijan in 2006 to that in 2010?
Offer a very short reply. 0.72. What is the ratio of the Net Disbursements (current US$) in OECD members in 2006 to that in 2011?
Keep it short and to the point. 0.06. What is the ratio of the Net Disbursements (current US$) in Sub-Saharan Africa (developing only) in 2006 to that in 2011?
Your answer should be very brief. 32.94. What is the ratio of the Net Disbursements (current US$) in Azerbaijan in 2006 to that in 2011?
Your answer should be very brief. 0.33. What is the ratio of the Net Disbursements (current US$) in Rwanda in 2006 to that in 2011?
Provide a short and direct response. 0.42. What is the ratio of the Net Disbursements (current US$) in OECD members in 2006 to that in 2012?
Your response must be concise. 0.43. What is the ratio of the Net Disbursements (current US$) of Sub-Saharan Africa (developing only) in 2006 to that in 2012?
Make the answer very short. 33.65. What is the ratio of the Net Disbursements (current US$) of Azerbaijan in 2006 to that in 2012?
Offer a terse response. 0.3. What is the ratio of the Net Disbursements (current US$) of Rwanda in 2006 to that in 2012?
Make the answer very short. 0.3. What is the ratio of the Net Disbursements (current US$) of Sub-Saharan Africa (developing only) in 2007 to that in 2008?
Offer a very short reply. 0.34. What is the ratio of the Net Disbursements (current US$) of Azerbaijan in 2007 to that in 2008?
Your response must be concise. 1.42. What is the ratio of the Net Disbursements (current US$) of Rwanda in 2007 to that in 2008?
Ensure brevity in your answer.  0.67. What is the ratio of the Net Disbursements (current US$) of OECD members in 2007 to that in 2009?
Keep it short and to the point. 2.33. What is the ratio of the Net Disbursements (current US$) of Sub-Saharan Africa (developing only) in 2007 to that in 2009?
Your response must be concise. 0.41. What is the ratio of the Net Disbursements (current US$) in Azerbaijan in 2007 to that in 2009?
Give a very brief answer. 2.14. What is the ratio of the Net Disbursements (current US$) in Rwanda in 2007 to that in 2009?
Your answer should be compact. 2.45. What is the ratio of the Net Disbursements (current US$) in OECD members in 2007 to that in 2010?
Your answer should be compact. 1.75. What is the ratio of the Net Disbursements (current US$) of Sub-Saharan Africa (developing only) in 2007 to that in 2010?
Offer a terse response. 1.41. What is the ratio of the Net Disbursements (current US$) of Azerbaijan in 2007 to that in 2010?
Provide a succinct answer. 2.61. What is the ratio of the Net Disbursements (current US$) in Rwanda in 2007 to that in 2010?
Offer a very short reply. 6.75. What is the ratio of the Net Disbursements (current US$) in OECD members in 2007 to that in 2011?
Provide a succinct answer. 0.45. What is the ratio of the Net Disbursements (current US$) in Sub-Saharan Africa (developing only) in 2007 to that in 2011?
Provide a succinct answer. 1.49. What is the ratio of the Net Disbursements (current US$) of Azerbaijan in 2007 to that in 2011?
Your response must be concise. 1.18. What is the ratio of the Net Disbursements (current US$) in Rwanda in 2007 to that in 2011?
Your answer should be very brief. 2.84. What is the ratio of the Net Disbursements (current US$) in Sub-Saharan Africa (developing only) in 2007 to that in 2012?
Your response must be concise. 1.52. What is the ratio of the Net Disbursements (current US$) in Azerbaijan in 2007 to that in 2012?
Keep it short and to the point. 1.09. What is the ratio of the Net Disbursements (current US$) of OECD members in 2008 to that in 2009?
Make the answer very short. 1.56. What is the ratio of the Net Disbursements (current US$) in Sub-Saharan Africa (developing only) in 2008 to that in 2009?
Provide a succinct answer. 1.19. What is the ratio of the Net Disbursements (current US$) of Rwanda in 2008 to that in 2009?
Make the answer very short. 3.68. What is the ratio of the Net Disbursements (current US$) in OECD members in 2008 to that in 2010?
Offer a very short reply. 1.17. What is the ratio of the Net Disbursements (current US$) of Sub-Saharan Africa (developing only) in 2008 to that in 2010?
Give a very brief answer. 4.1. What is the ratio of the Net Disbursements (current US$) of Azerbaijan in 2008 to that in 2010?
Your answer should be very brief. 1.83. What is the ratio of the Net Disbursements (current US$) of Rwanda in 2008 to that in 2010?
Provide a succinct answer. 10.12. What is the ratio of the Net Disbursements (current US$) in OECD members in 2008 to that in 2011?
Provide a succinct answer. 0.3. What is the ratio of the Net Disbursements (current US$) in Sub-Saharan Africa (developing only) in 2008 to that in 2011?
Offer a very short reply. 4.33. What is the ratio of the Net Disbursements (current US$) of Azerbaijan in 2008 to that in 2011?
Your response must be concise. 0.82. What is the ratio of the Net Disbursements (current US$) of Rwanda in 2008 to that in 2011?
Ensure brevity in your answer.  4.26. What is the ratio of the Net Disbursements (current US$) in OECD members in 2008 to that in 2012?
Your answer should be very brief. 2. What is the ratio of the Net Disbursements (current US$) of Sub-Saharan Africa (developing only) in 2008 to that in 2012?
Keep it short and to the point. 4.42. What is the ratio of the Net Disbursements (current US$) in Azerbaijan in 2008 to that in 2012?
Ensure brevity in your answer.  0.77. What is the ratio of the Net Disbursements (current US$) of Rwanda in 2008 to that in 2012?
Your answer should be very brief. 3. What is the ratio of the Net Disbursements (current US$) of Sub-Saharan Africa (developing only) in 2009 to that in 2010?
Keep it short and to the point. 3.45. What is the ratio of the Net Disbursements (current US$) in Azerbaijan in 2009 to that in 2010?
Provide a short and direct response. 1.22. What is the ratio of the Net Disbursements (current US$) in Rwanda in 2009 to that in 2010?
Your response must be concise. 2.75. What is the ratio of the Net Disbursements (current US$) of OECD members in 2009 to that in 2011?
Make the answer very short. 0.19. What is the ratio of the Net Disbursements (current US$) in Sub-Saharan Africa (developing only) in 2009 to that in 2011?
Give a very brief answer. 3.65. What is the ratio of the Net Disbursements (current US$) of Azerbaijan in 2009 to that in 2011?
Offer a terse response. 0.55. What is the ratio of the Net Disbursements (current US$) in Rwanda in 2009 to that in 2011?
Your response must be concise. 1.16. What is the ratio of the Net Disbursements (current US$) in OECD members in 2009 to that in 2012?
Ensure brevity in your answer.  1.29. What is the ratio of the Net Disbursements (current US$) of Sub-Saharan Africa (developing only) in 2009 to that in 2012?
Your response must be concise. 3.73. What is the ratio of the Net Disbursements (current US$) in Azerbaijan in 2009 to that in 2012?
Keep it short and to the point. 0.51. What is the ratio of the Net Disbursements (current US$) of Rwanda in 2009 to that in 2012?
Your answer should be very brief. 0.81. What is the ratio of the Net Disbursements (current US$) in OECD members in 2010 to that in 2011?
Make the answer very short. 0.26. What is the ratio of the Net Disbursements (current US$) of Sub-Saharan Africa (developing only) in 2010 to that in 2011?
Ensure brevity in your answer.  1.06. What is the ratio of the Net Disbursements (current US$) of Azerbaijan in 2010 to that in 2011?
Offer a very short reply. 0.45. What is the ratio of the Net Disbursements (current US$) of Rwanda in 2010 to that in 2011?
Your answer should be compact. 0.42. What is the ratio of the Net Disbursements (current US$) in OECD members in 2010 to that in 2012?
Offer a terse response. 1.71. What is the ratio of the Net Disbursements (current US$) of Sub-Saharan Africa (developing only) in 2010 to that in 2012?
Provide a short and direct response. 1.08. What is the ratio of the Net Disbursements (current US$) of Azerbaijan in 2010 to that in 2012?
Keep it short and to the point. 0.42. What is the ratio of the Net Disbursements (current US$) in Rwanda in 2010 to that in 2012?
Ensure brevity in your answer.  0.3. What is the ratio of the Net Disbursements (current US$) in OECD members in 2011 to that in 2012?
Offer a very short reply. 6.71. What is the ratio of the Net Disbursements (current US$) in Sub-Saharan Africa (developing only) in 2011 to that in 2012?
Keep it short and to the point. 1.02. What is the ratio of the Net Disbursements (current US$) of Azerbaijan in 2011 to that in 2012?
Offer a very short reply. 0.93. What is the ratio of the Net Disbursements (current US$) in Rwanda in 2011 to that in 2012?
Ensure brevity in your answer.  0.7. What is the difference between the highest and the second highest Net Disbursements (current US$) of Sub-Saharan Africa (developing only)?
Offer a terse response. 8.12e+07. What is the difference between the highest and the lowest Net Disbursements (current US$) in Sub-Saharan Africa (developing only)?
Give a very brief answer. 9.26e+07. What is the difference between the highest and the lowest Net Disbursements (current US$) in Azerbaijan?
Keep it short and to the point. 4.40e+05. What is the difference between the highest and the lowest Net Disbursements (current US$) in Rwanda?
Your answer should be very brief. 7.90e+05. 